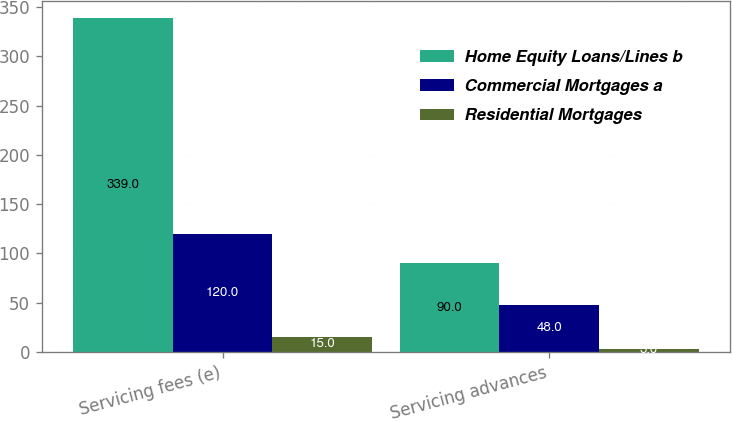Convert chart to OTSL. <chart><loc_0><loc_0><loc_500><loc_500><stacked_bar_chart><ecel><fcel>Servicing fees (e)<fcel>Servicing advances<nl><fcel>Home Equity Loans/Lines b<fcel>339<fcel>90<nl><fcel>Commercial Mortgages a<fcel>120<fcel>48<nl><fcel>Residential Mortgages<fcel>15<fcel>3<nl></chart> 